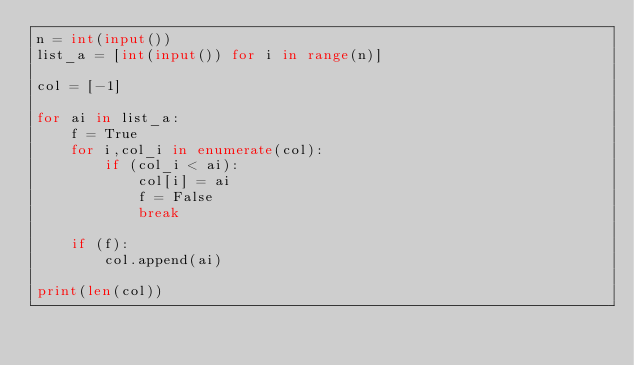Convert code to text. <code><loc_0><loc_0><loc_500><loc_500><_Python_>n = int(input())
list_a = [int(input()) for i in range(n)]

col = [-1]

for ai in list_a:
    f = True
    for i,col_i in enumerate(col):
        if (col_i < ai):
            col[i] = ai
            f = False
            break
    
    if (f):
        col.append(ai)

print(len(col))
            
</code> 